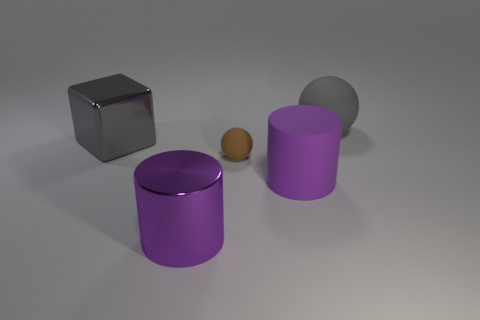Subtract all cyan spheres. Subtract all cyan cylinders. How many spheres are left? 2 Add 1 metallic cylinders. How many objects exist? 6 Subtract all cylinders. How many objects are left? 3 Subtract 0 cyan balls. How many objects are left? 5 Subtract all large red things. Subtract all large gray things. How many objects are left? 3 Add 5 cylinders. How many cylinders are left? 7 Add 1 big purple rubber cylinders. How many big purple rubber cylinders exist? 2 